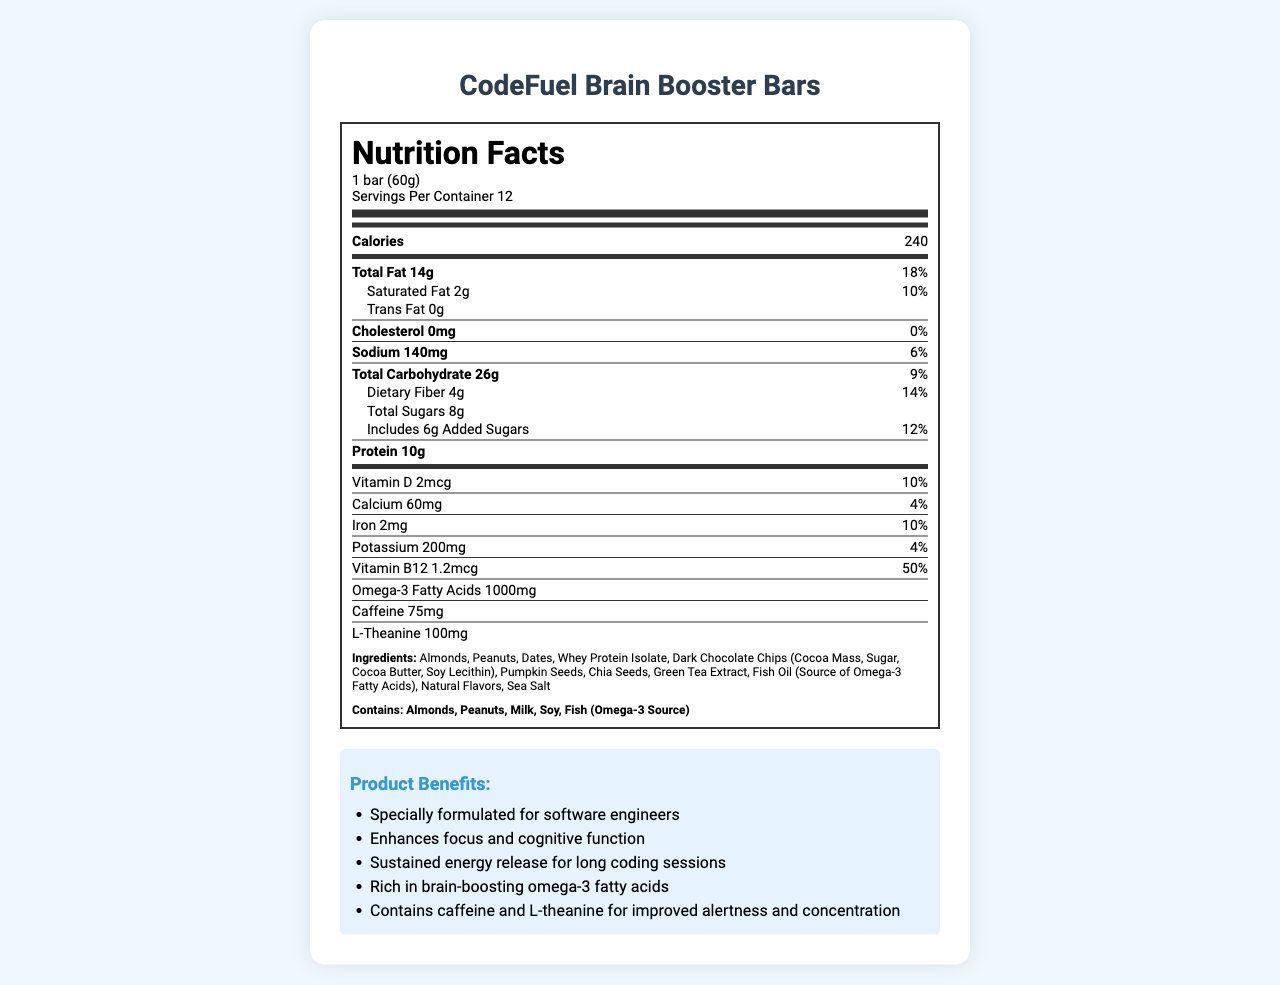What is the serving size for CodeFuel Brain Booster Bars? The serving size is listed as "1 bar (60g)" under the Nutrition Facts section.
Answer: 1 bar (60g) How many calories are in one serving of CodeFuel Brain Booster Bars? The calorie information is provided in the Nutrition Facts section, which shows 240 calories per serving.
Answer: 240 calories What is the total fat content in one bar? The total fat content is indicated as "Total Fat 14g" in the Nutrition Facts section.
Answer: 14g Which vitamin has the highest daily value percentage? A. Vitamin D B. Calcium C. Iron D. Vitamin B12 The daily value for Vitamin B12 is listed as 50%, which is higher than the percentages listed for Vitamin D (10%), Calcium (4%), and Iron (10%).
Answer: D. Vitamin B12 What allergens are contained in CodeFuel Brain Booster Bars? The allergen information is listed as "Contains: Almonds, Peanuts, Milk, Soy, Fish (Omega-3 Source)" near the Nutrition Facts section.
Answer: Almonds, Peanuts, Milk, Soy, Fish (Omega-3 Source) Does this product contain caffeine? The Nutrition Facts section lists "Caffeine 75mg" indicating that the product contains caffeine.
Answer: Yes How much protein is in one bar? The protein content is listed as "Protein 10g" in the Nutrition Facts section.
Answer: 10g What is the amount of omega-3 fatty acids in a serving? The Nutrition Facts section specifies "Omega-3 Fatty Acids 1000mg."
Answer: 1000mg Which ingredient is not listed in the product? A. Almonds B. Dates C. Honey D. Pumpkin Seeds Honey is not mentioned among the ingredients, while Almonds, Dates, and Pumpkin Seeds are listed.
Answer: C. Honey Does this product contain any trans fats? The Nutrition Facts section shows "Trans Fat 0g," indicating that there are no trans fats in this product.
Answer: No How many servings are there in one container? Under the Nutrition Facts, it states "Servings Per Container 12."
Answer: 12 What is the main idea of the document? The document provides comprehensive details about the product, including nutritional breakdown per serving, ingredients, allergens, and marketing claims, highlighting its benefits for cognitive function and energy enhancement.
Answer: The CodeFuel Brain Booster Bars nutrition label provides detailed nutritional information, ingredient list, allergen warnings, and marketing claims aimed at software engineers to promote enhanced focus and sustained energy. What is the amount of added sugars in one bar? The Nutrition Facts section indicates "Includes 6g Added Sugars."
Answer: 6g What is the main source of omega-3 fatty acids in the ingredients list? The ingredients list mentions "Fish Oil (Source of Omega-3 Fatty Acids)" as the source.
Answer: Fish Oil What is the daily value percentage of saturated fat in one serving of the bar? Under the Nutrition Facts section, the daily value for "Saturated Fat" is listed as 10%.
Answer: 10% How much dietary fiber does one bar contain? The Nutrition Facts section shows "Dietary Fiber 4g," indicating the fiber content per bar.
Answer: 4g Which of the following marketing claims is not mentioned for the product? A. Enhances focus and cognitive function B. Vegan-friendly C. Sustained energy release for long coding sessions D. Rich in brain-boosting omega-3 fatty acids The document mentions claims A, C, and D in the marketing claims section, but it does not claim the product is vegan-friendly.
Answer: B. Vegan-friendly What is the sodium content in one bar? The Nutrition Facts section states "Sodium 140mg."
Answer: 140mg Is the product specially formulated for software engineers? The marketing claims section states "Specially formulated for software engineers."
Answer: Yes What is the total carbohydrate content in one serving? The Nutrition Facts section indicates "Total Carbohydrate 26g."
Answer: 26g What percentage of the daily value of calcium is provided in one serving? The daily value for calcium is listed as 4% in the Nutrition Facts section.
Answer: 4% 